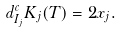Convert formula to latex. <formula><loc_0><loc_0><loc_500><loc_500>d ^ { c } _ { I _ { j } } K _ { j } ( T ) = 2 x _ { j } .</formula> 